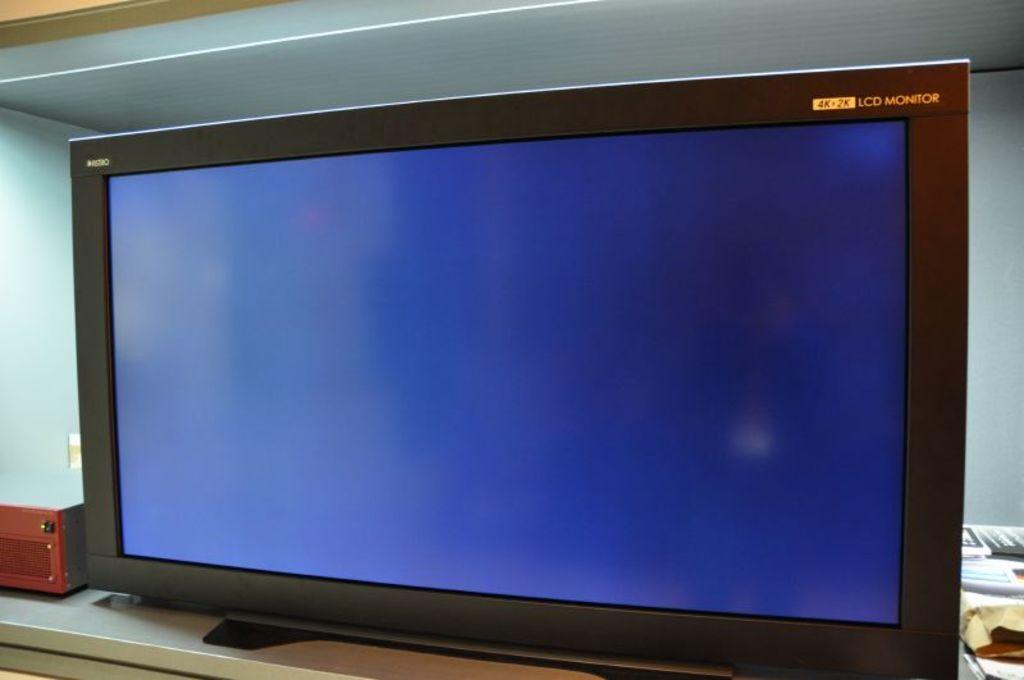Is this a 4k monitor?
Your answer should be compact. Yes. 